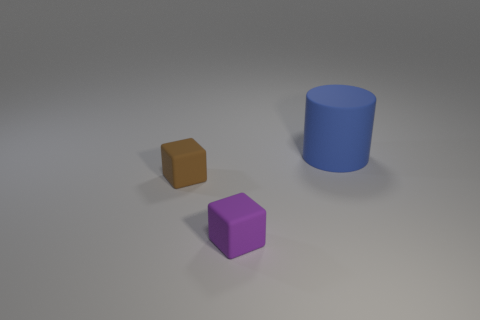The large object that is the same material as the purple cube is what shape?
Keep it short and to the point. Cylinder. Is the small cube that is right of the brown matte thing made of the same material as the blue object?
Give a very brief answer. Yes. There is a tiny cube on the right side of the brown rubber object; does it have the same color as the tiny object that is behind the tiny purple matte cube?
Give a very brief answer. No. How many things are both behind the tiny purple thing and left of the large matte cylinder?
Make the answer very short. 1. What is the blue object made of?
Ensure brevity in your answer.  Rubber. What shape is the brown thing that is the same size as the purple rubber block?
Make the answer very short. Cube. Are the thing in front of the small brown block and the block left of the purple cube made of the same material?
Ensure brevity in your answer.  Yes. What number of blue matte cylinders are there?
Your answer should be very brief. 1. What number of other purple objects are the same shape as the large rubber thing?
Provide a short and direct response. 0. Does the big rubber thing have the same shape as the purple thing?
Your answer should be very brief. No. 